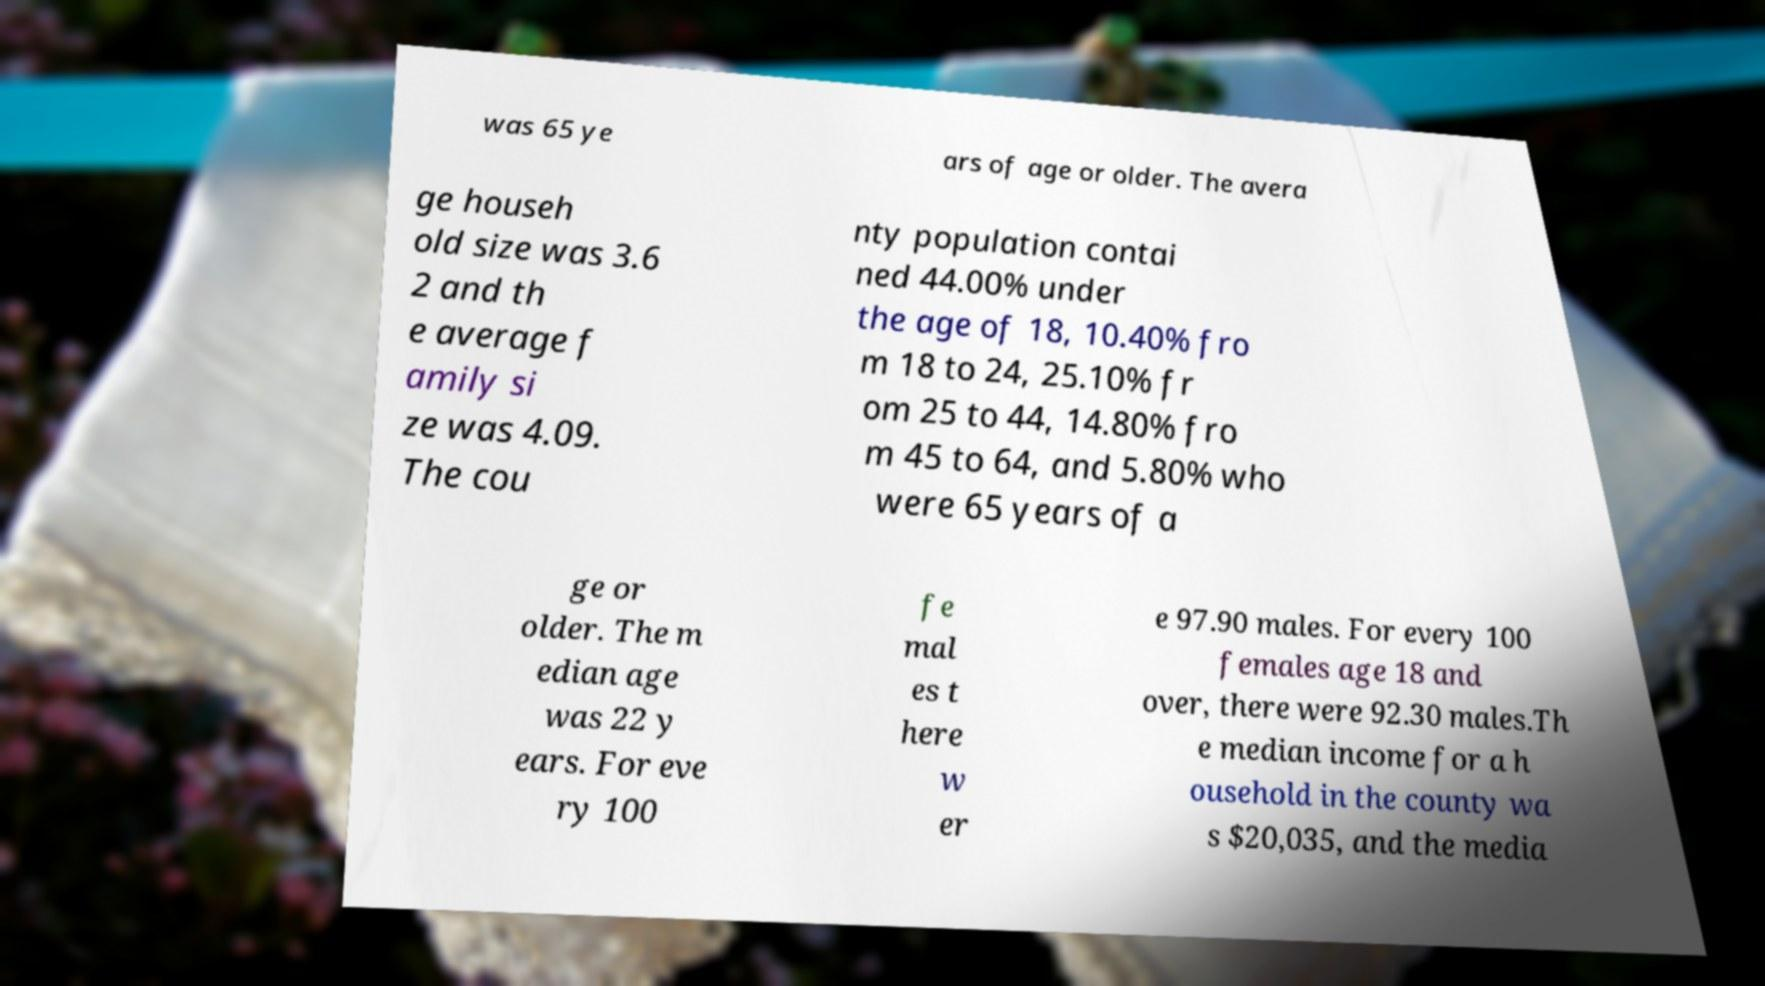For documentation purposes, I need the text within this image transcribed. Could you provide that? was 65 ye ars of age or older. The avera ge househ old size was 3.6 2 and th e average f amily si ze was 4.09. The cou nty population contai ned 44.00% under the age of 18, 10.40% fro m 18 to 24, 25.10% fr om 25 to 44, 14.80% fro m 45 to 64, and 5.80% who were 65 years of a ge or older. The m edian age was 22 y ears. For eve ry 100 fe mal es t here w er e 97.90 males. For every 100 females age 18 and over, there were 92.30 males.Th e median income for a h ousehold in the county wa s $20,035, and the media 